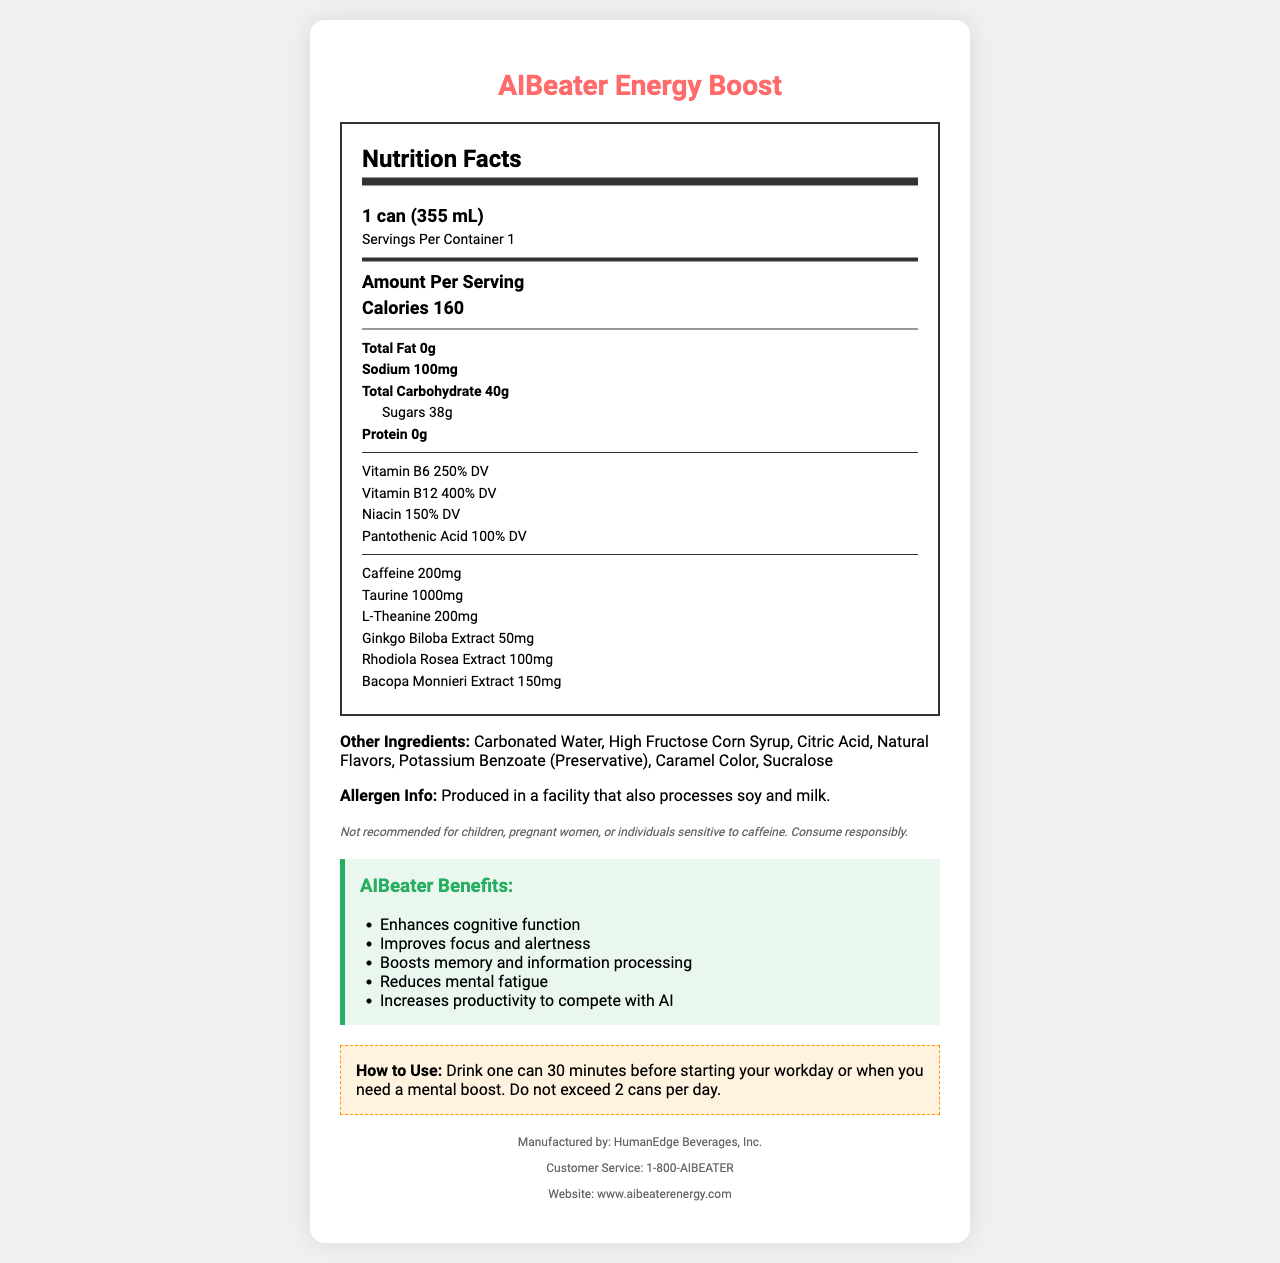what is the serving size? The serving size is clearly listed at the top of the nutrition facts as "1 can (355 mL)".
Answer: 1 can (355 mL) how many calories are in one serving of AIBeater Energy Boost? The amount of calories per serving is listed as "Calories 160".
Answer: 160 how much caffeine does one can contain? The amount of caffeine is listed in the nutrition facts section as "Caffeine 200mg".
Answer: 200mg what are the main vitamins contained in AIBeater Energy Boost? The main vitamins are listed in the nutrition facts with their respective daily values as Vitamin B6 (250% DV), Vitamin B12 (400% DV), Niacin (150% DV), and Pantothenic Acid (100% DV).
Answer: Vitamin B6, Vitamin B12, Niacin, Pantothenic Acid what are the marketing claims made by AIBeater Energy Boost? The marketing claims are listed under the "AIBeater Benefits" section with bullet points.
Answer: Enhances cognitive function, Improves focus and alertness, Boosts memory and information processing, Reduces mental fatigue, Increases productivity to compete with AI what is the sodium content per serving? Sodium content is found in the nutrition facts section, listed as "Sodium 100mg".
Answer: 100mg which of the following ingredients is not listed in the "Other Ingredients" section? A. Caramel Color B. Citric Acid C. Stevia D. High Fructose Corn Syrup The document lists "Caramel Color", "Citric Acid", and "High Fructose Corn Syrup" under "Other Ingredients", but not Stevia.
Answer: C. Stevia how many grams of sugar are in one can? The sugar content is listed as part of the total carbohydrate section, specified as "Sugars 38g”.
Answer: 38g how should AIBeater Energy Boost be used for optimal performance? A. Drink one can in the morning B. Drink one can 30 minutes before starting your workday or when you need a mental boost C. Drink one can before bed D. Drink three cans a day The document specifies the usage instructions as "Drink one can 30 minutes before starting your workday or when you need a mental boost. Do not exceed 2 cans per day."
Answer: B. Drink one can 30 minutes before starting your workday or when you need a mental boost is AIBeater Energy Boost recommended for children? The disclaimer states, “Not recommended for children, pregnant women, or individuals sensitive to caffeine.”
Answer: No what is the primary purpose of AIBeater Energy Boost according to the document? The marketing claims section highlights the primary purpose as enhancing cognitive function, improving focus, boosting memory, reducing mental fatigue, and increasing productivity to compete with AI.
Answer: To enhance cognitive function and increase productivity to compete with AI does the document state if AIBeater Energy Boost is gluten-free? The document does not mention whether AIBeater Energy Boost is gluten-free. It only provides allergen information stating it is produced in a facility that processes soy and milk.
Answer: Not enough information summarize the main details provided in the document. This summary captures the essence of the document, including the nutritional information, intended benefits, usage instructions, and disclaimers.
Answer: AIBeater Energy Boost is an energy drink designed to enhance cognitive function and productivity, especially to compete with AI in the workplace. It contains high levels of vitamins B6, B12, niacin, and pantothenic acid, along with 200mg of caffeine, taurine, L-theanine, and herbal extracts like ginkgo biloba, rhodiola rosea, and bacopa monnieri. It has a serving size of one can (355 mL) containing 160 calories and 38g of sugars. The drink should be consumed responsibly, with a maximum of two cans per day, and is not recommended for children, pregnant women, or individuals sensitive to caffeine. 